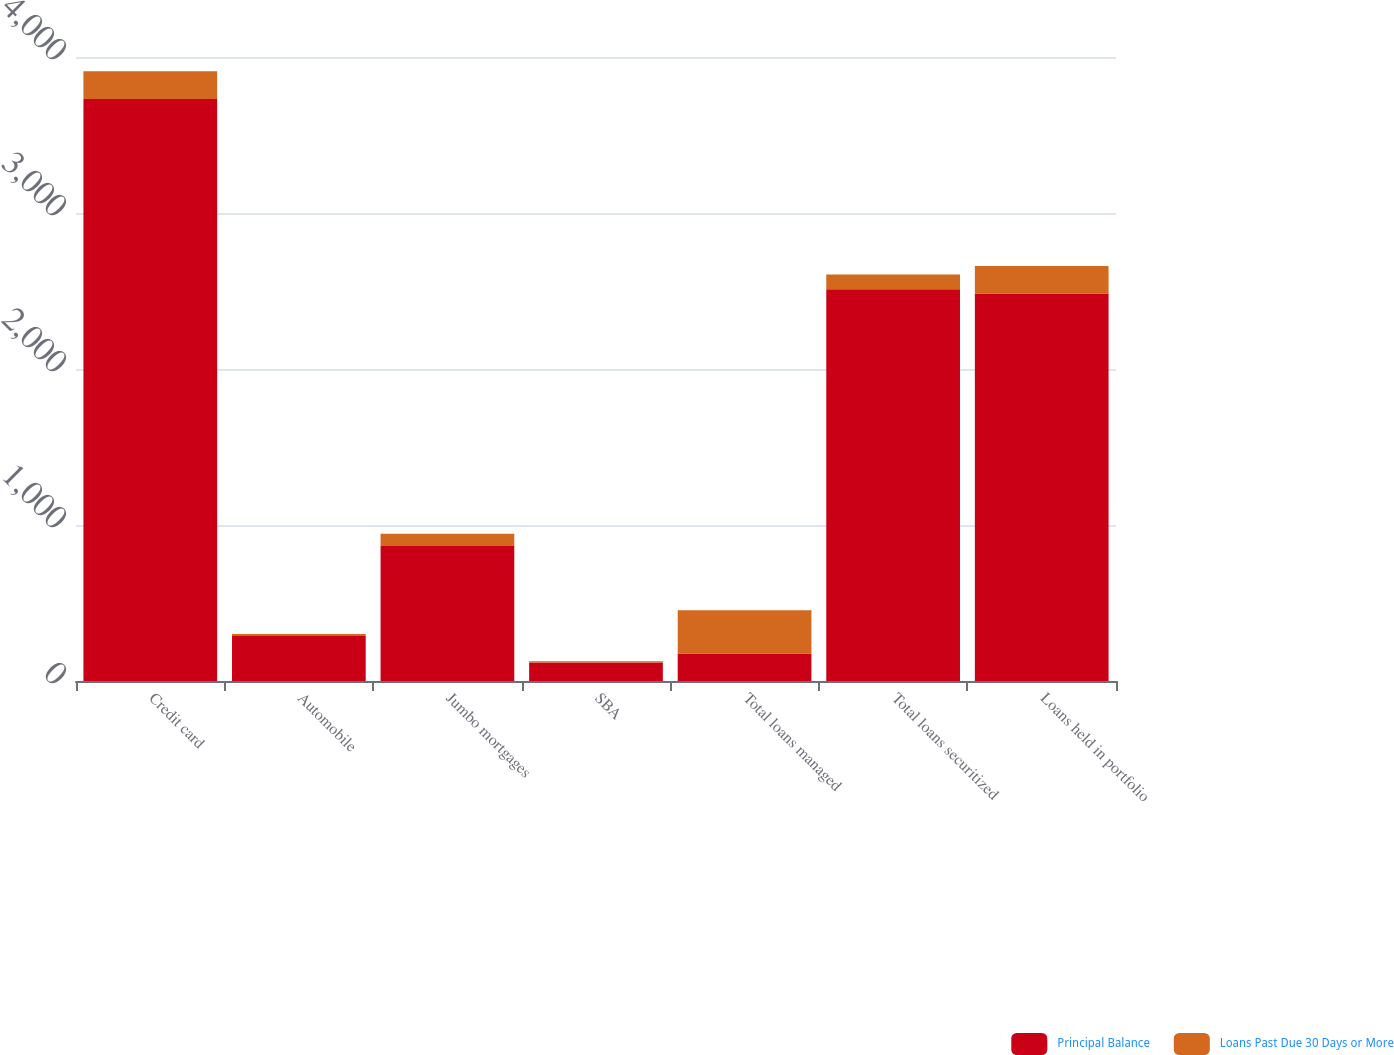Convert chart. <chart><loc_0><loc_0><loc_500><loc_500><stacked_bar_chart><ecel><fcel>Credit card<fcel>Automobile<fcel>Jumbo mortgages<fcel>SBA<fcel>Total loans managed<fcel>Total loans securitized<fcel>Loans held in portfolio<nl><fcel>Principal Balance<fcel>3731<fcel>289<fcel>866<fcel>118<fcel>177<fcel>2511<fcel>2484<nl><fcel>Loans Past Due 30 Days or More<fcel>177<fcel>13<fcel>78<fcel>8<fcel>276<fcel>95<fcel>177<nl></chart> 